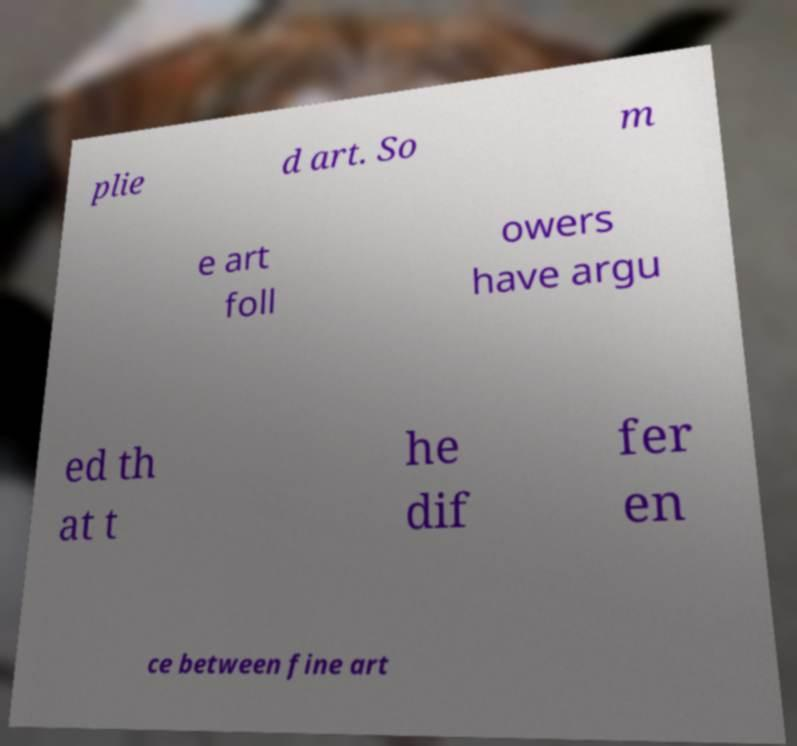Can you accurately transcribe the text from the provided image for me? plie d art. So m e art foll owers have argu ed th at t he dif fer en ce between fine art 